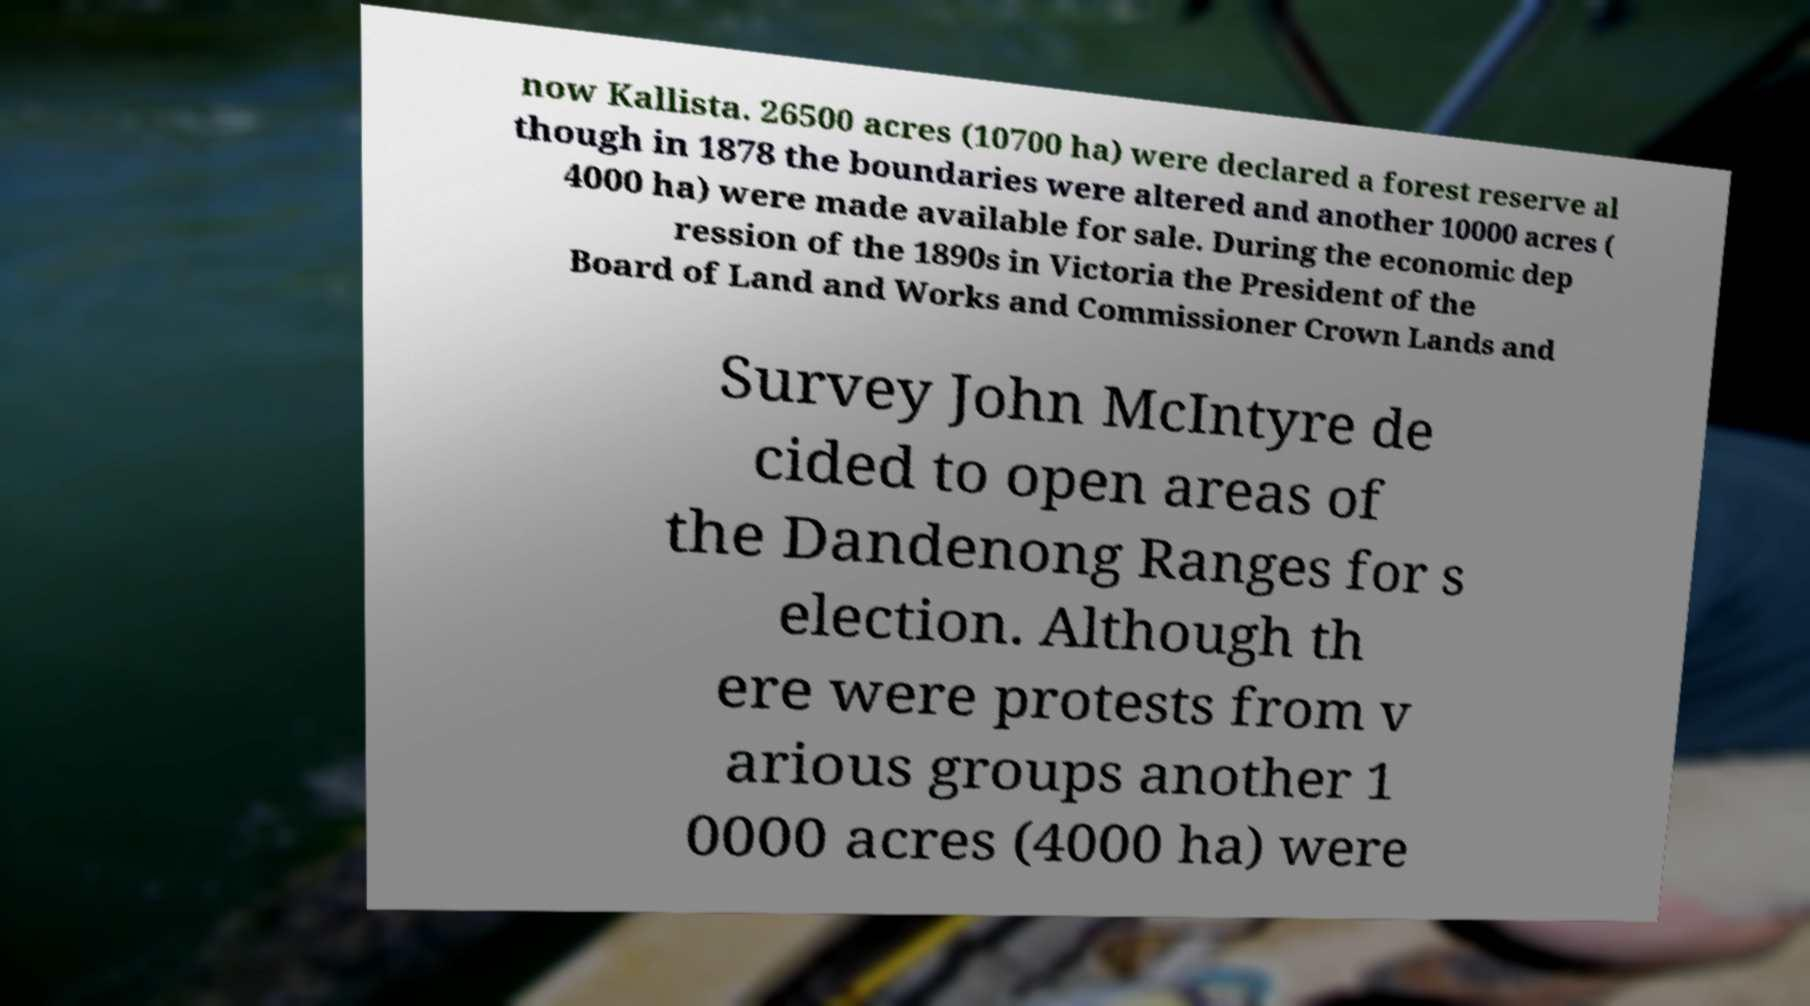Please read and relay the text visible in this image. What does it say? now Kallista. 26500 acres (10700 ha) were declared a forest reserve al though in 1878 the boundaries were altered and another 10000 acres ( 4000 ha) were made available for sale. During the economic dep ression of the 1890s in Victoria the President of the Board of Land and Works and Commissioner Crown Lands and Survey John McIntyre de cided to open areas of the Dandenong Ranges for s election. Although th ere were protests from v arious groups another 1 0000 acres (4000 ha) were 